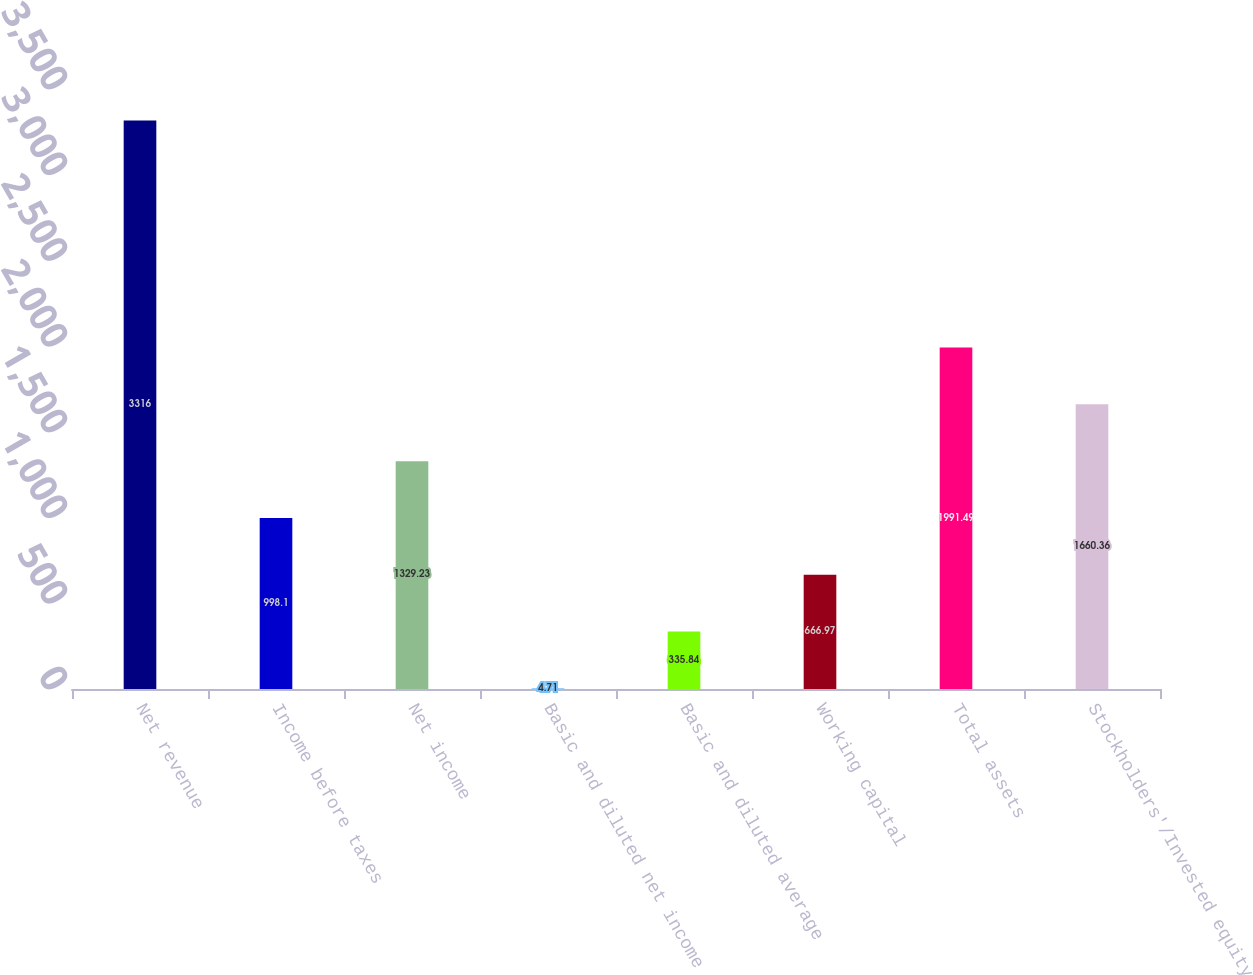Convert chart to OTSL. <chart><loc_0><loc_0><loc_500><loc_500><bar_chart><fcel>Net revenue<fcel>Income before taxes<fcel>Net income<fcel>Basic and diluted net income<fcel>Basic and diluted average<fcel>Working capital<fcel>Total assets<fcel>Stockholders'/Invested equity<nl><fcel>3316<fcel>998.1<fcel>1329.23<fcel>4.71<fcel>335.84<fcel>666.97<fcel>1991.49<fcel>1660.36<nl></chart> 